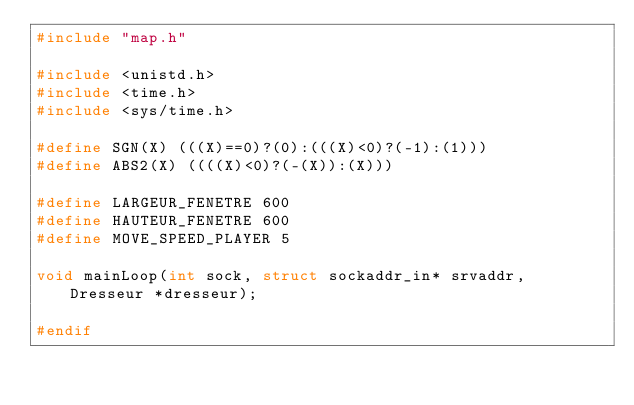<code> <loc_0><loc_0><loc_500><loc_500><_C_>#include "map.h"

#include <unistd.h>
#include <time.h>
#include <sys/time.h>

#define SGN(X) (((X)==0)?(0):(((X)<0)?(-1):(1)))
#define ABS2(X) ((((X)<0)?(-(X)):(X)))

#define LARGEUR_FENETRE 600
#define HAUTEUR_FENETRE 600
#define MOVE_SPEED_PLAYER 5

void mainLoop(int sock, struct sockaddr_in* srvaddr, Dresseur *dresseur);

#endif</code> 